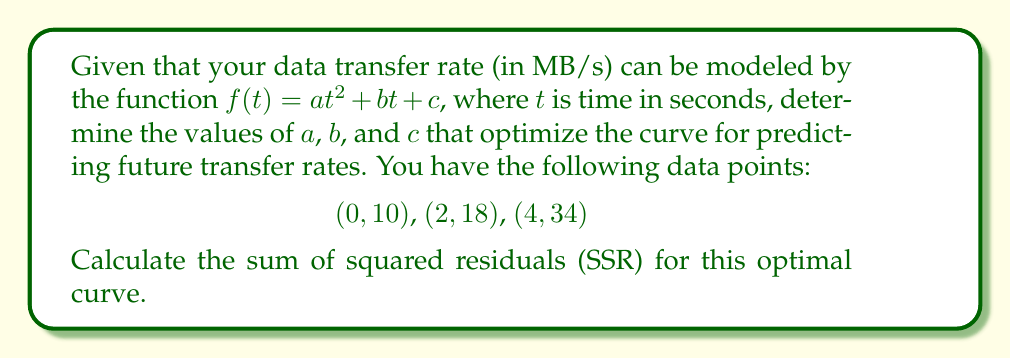Solve this math problem. 1) To find the optimal curve, we need to solve a system of equations using the given data points:

   $10 = c$
   $18 = 4a + 2b + c$
   $34 = 16a + 4b + c$

2) Substituting $c = 10$ into the other equations:

   $8 = 4a + 2b$
   $24 = 16a + 4b$

3) Multiply the first equation by 2:

   $16 = 8a + 4b$
   $24 = 16a + 4b$

4) Subtract the first equation from the second:

   $8 = 8a$
   $a = 1$

5) Substitute $a = 1$ back into $8 = 4a + 2b$:

   $8 = 4 + 2b$
   $4 = 2b$
   $b = 2$

6) Therefore, the optimal curve is:

   $f(t) = t^2 + 2t + 10$

7) To calculate the SSR, we need to find the sum of the squared differences between the actual and predicted values:

   For $t = 0$: $(10 - 10)^2 = 0$
   For $t = 2$: $(18 - (4 + 4 + 10))^2 = 0$
   For $t = 4$: $(34 - (16 + 8 + 10))^2 = 0$

8) The sum of these squared residuals is:

   $SSR = 0 + 0 + 0 = 0$
Answer: $f(t) = t^2 + 2t + 10$, SSR $= 0$ 